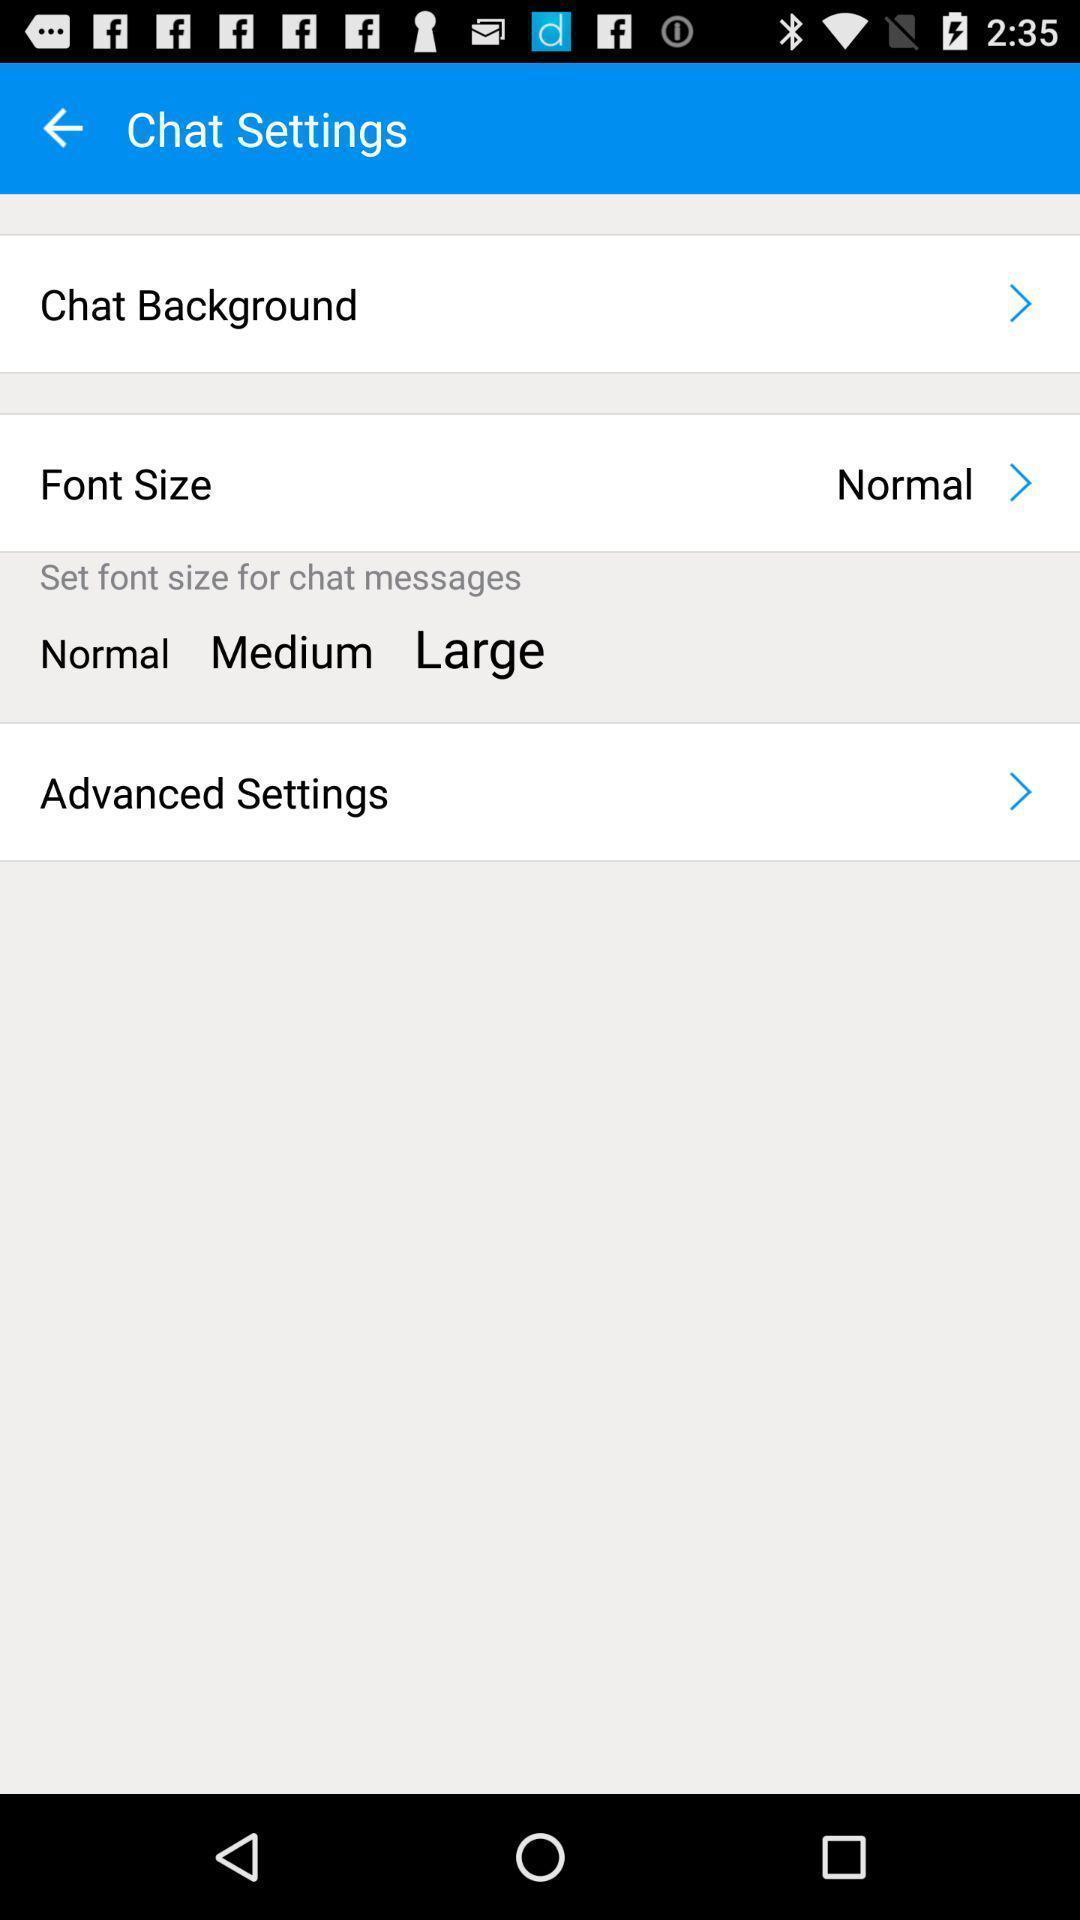Tell me about the visual elements in this screen capture. Page displaying chat settings. 